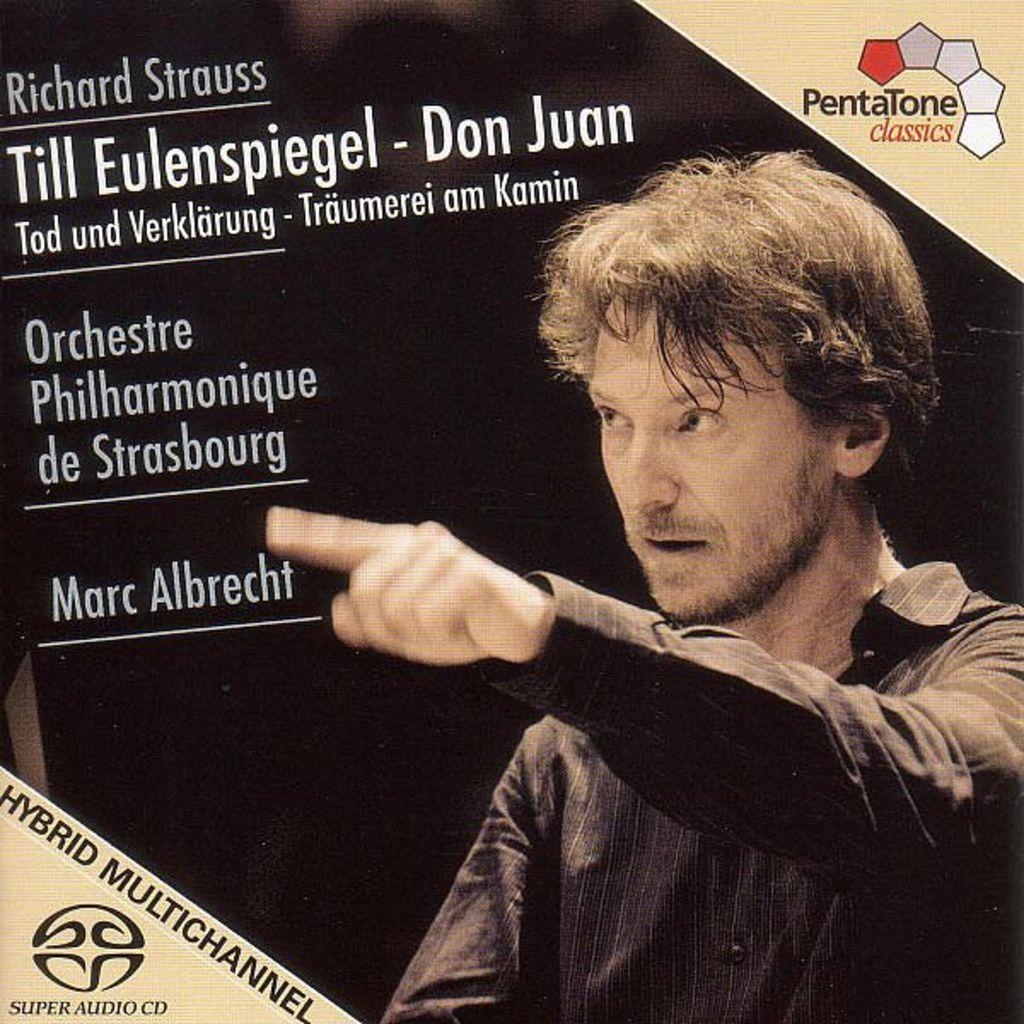What is the main object in the image? There is a magazine in the image. What can be seen on the cover of the magazine? The magazine has an image of a man wearing a black shirt. What is the man doing in the image? The man is raising his hand in the image. Is there any text or additional information on the magazine cover? Yes, there is additional information beside the man's image. What type of pot is visible in the image? There is no pot present in the image; it features a magazine with an image of a man wearing a black shirt. How many socks can be seen on the man's feet in the image? The image does not show the man's feet, so it is impossible to determine if he is wearing socks or how many. 